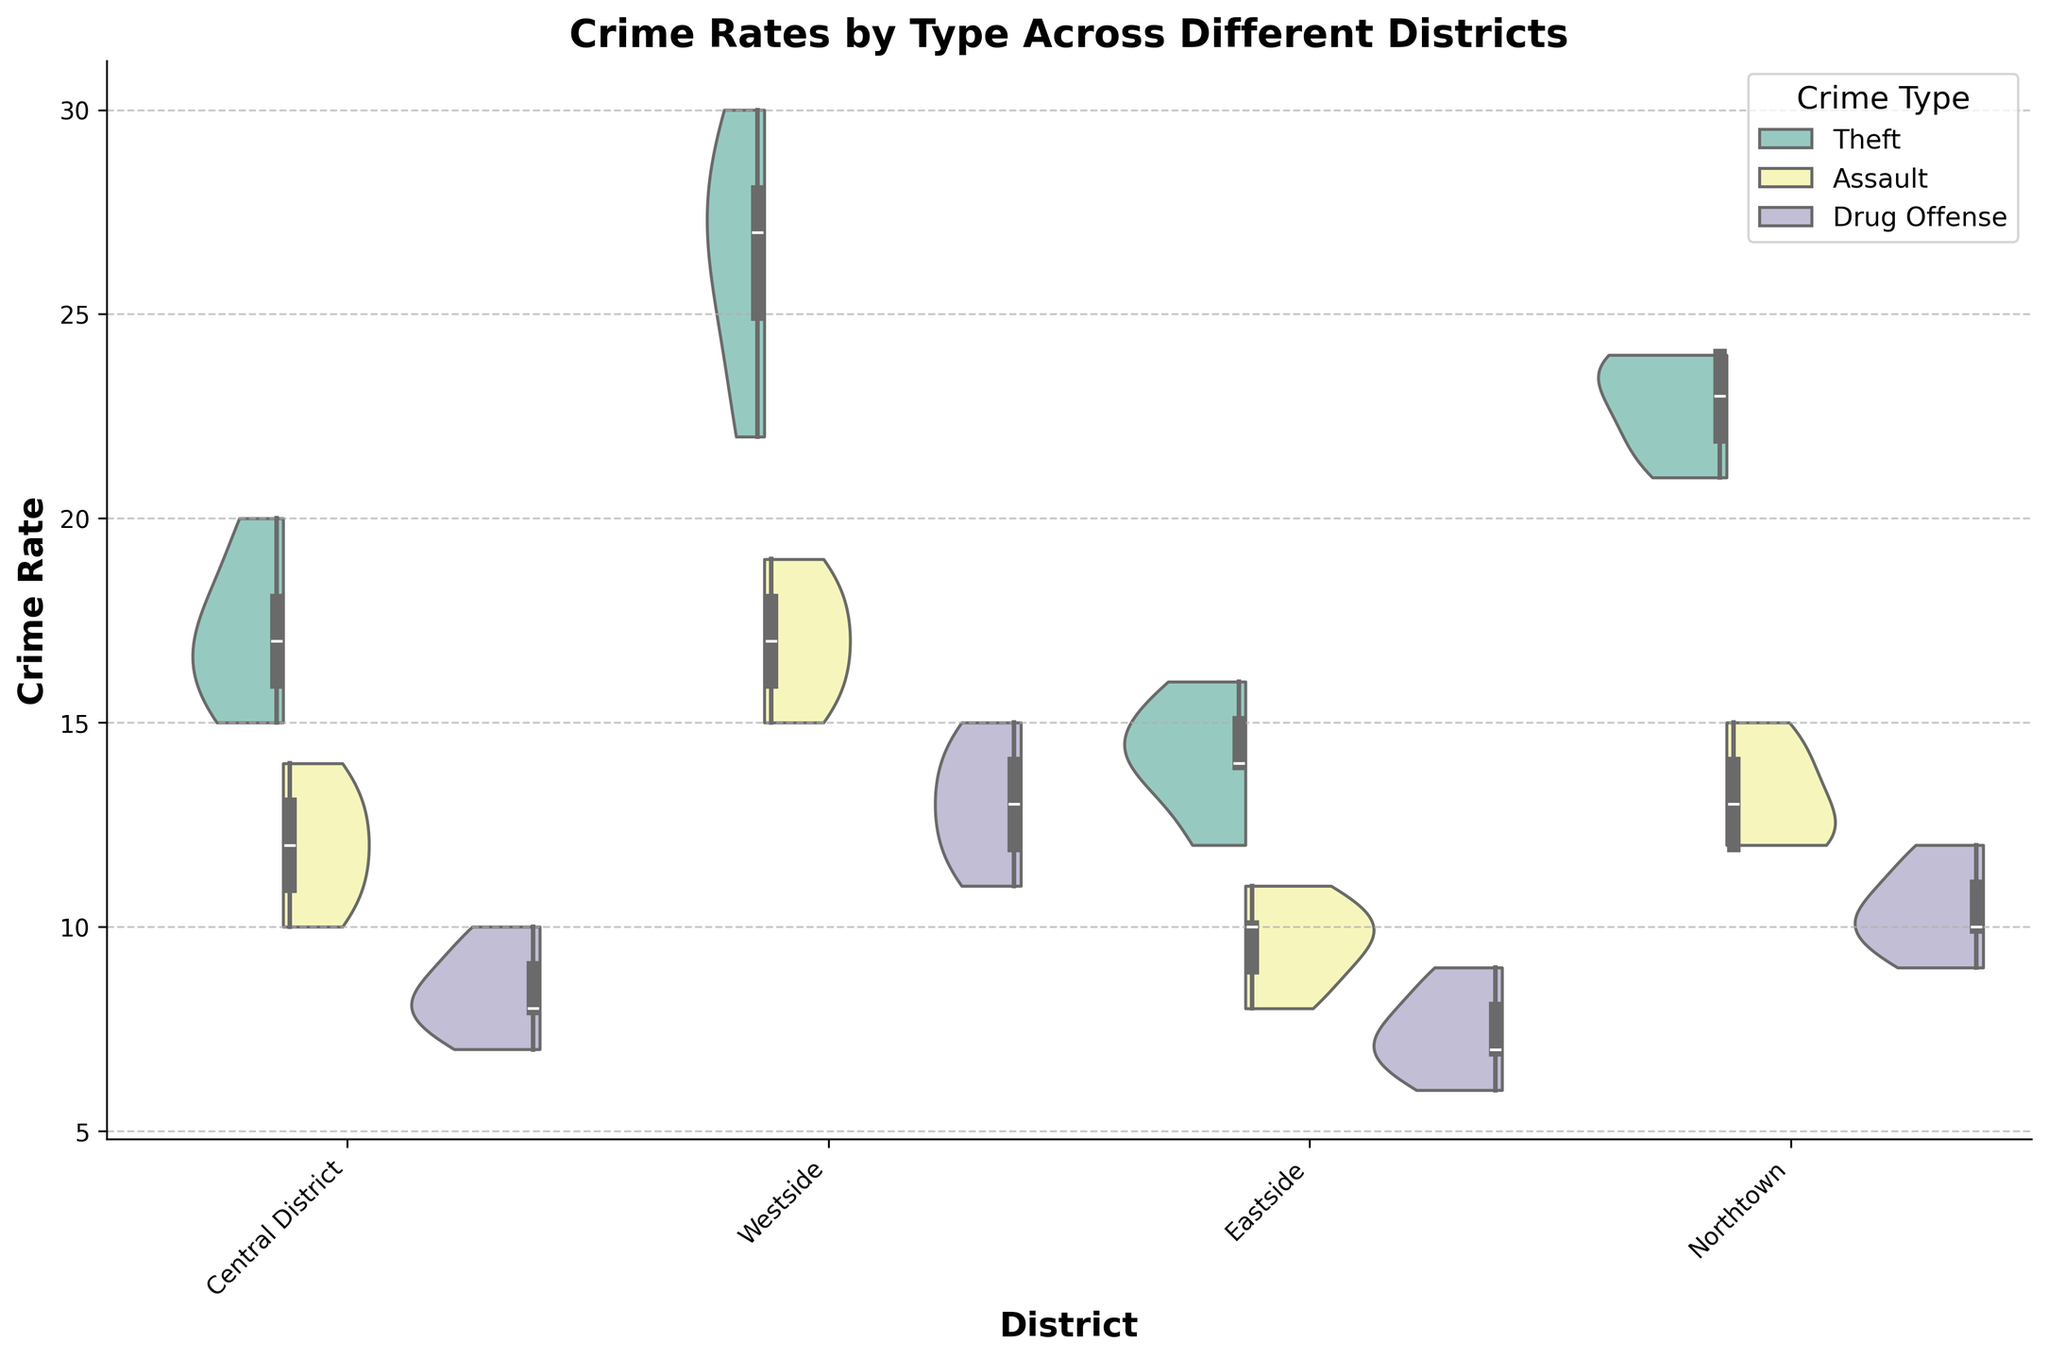What is the title of the figure? The title of the figure is located at the top of the chart and provides a summary of the data presented.
Answer: Crime Rates by Type Across Different Districts Which district has the highest median crime rate for Theft? The box plot overlay within the violin plot highlights the median for each category. The Westside district has the highest median crime rate for Theft.
Answer: Westside Compare the spread of Assault rates between Central District and Eastside. Which district shows higher variability? The spread or variability can be seen from the width of the violin plot. The Central District has a wider spread for Assault rates compared to Eastside, indicating higher variability.
Answer: Central District Which crime type shows the most consistent rates in the Eastside district? Consistency can be inferred from narrower distributions. The Drug Offense crime type in Eastside shows the most consistent rates, indicated by the narrowest spread in the violin plot.
Answer: Drug Offense How does the median crime rate for Drug Offense in Northtown compare to that in Central District? Checking the median line within the box plot for Drug Offense in both districts, we see that the median in Northtown is slightly higher than in Central District.
Answer: Higher in Northtown Are there any districts where the crime rate for Assault overlaps greatly with Theft? Overlap can be seen in the merged areas of the split violin plots. In the Westside district, the Assault and Theft categories show significant overlap.
Answer: Westside Calculate the interquartile range (IQR) for Assault in the Northtown district. The IQR is the range between the 25th and 75th percentiles, shown by the box in the plot. For Assault in Northtown, the 25th percentile is 12 and the 75th is 14, so the IQR is 14 - 12 = 2.
Answer: 2 Which district exhibits the widest distribution in the Crime Rate for Theft? The widest distribution can be identified by the violin plots that are widest. Westside displays the widest distribution in the Crime Rate for Theft.
Answer: Westside Is there a crime type in any district where the minimum and maximum rates are almost the same? We look for the narrowest and almost flat violin plots. Drug Offense in Eastside shows very similar minimum and maximum rates, indicated by its narrow distribution.
Answer: Drug Offense in Eastside 